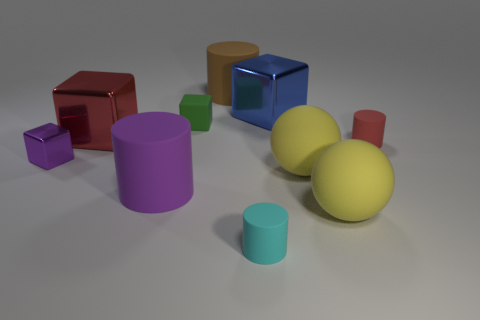Is the number of small green rubber objects in front of the tiny green thing greater than the number of small purple blocks?
Provide a short and direct response. No. The purple object that is the same material as the tiny red cylinder is what size?
Make the answer very short. Large. What number of big rubber cylinders are the same color as the tiny shiny thing?
Keep it short and to the point. 1. Is the color of the large cylinder in front of the small purple cube the same as the small metallic thing?
Ensure brevity in your answer.  Yes. Are there the same number of large brown rubber cylinders that are behind the large brown rubber cylinder and big matte cylinders in front of the purple cylinder?
Ensure brevity in your answer.  Yes. Is there any other thing that is made of the same material as the large brown thing?
Make the answer very short. Yes. There is a block in front of the small red cylinder; what is its color?
Ensure brevity in your answer.  Purple. Are there the same number of large red metallic things to the right of the small cyan cylinder and brown rubber things?
Offer a terse response. No. How many other things are the same shape as the blue shiny object?
Offer a very short reply. 3. What number of tiny green objects are in front of the large red thing?
Your answer should be compact. 0. 